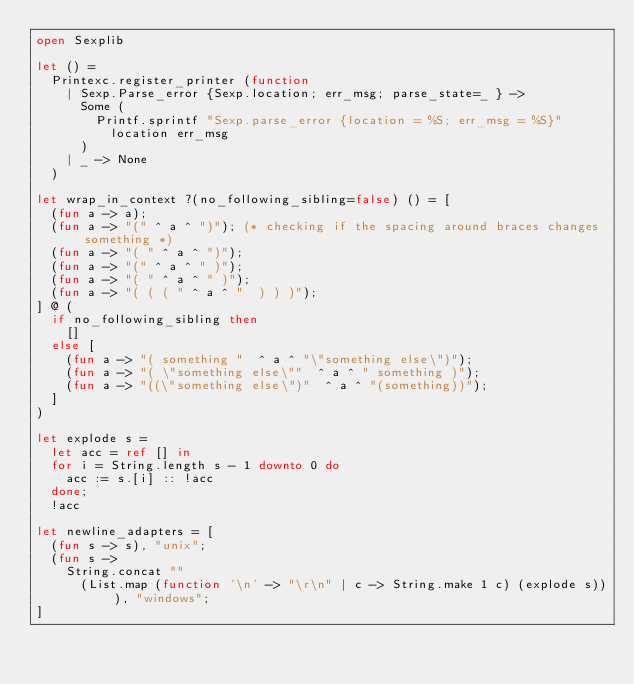<code> <loc_0><loc_0><loc_500><loc_500><_OCaml_>open Sexplib

let () =
  Printexc.register_printer (function
    | Sexp.Parse_error {Sexp.location; err_msg; parse_state=_ } ->
      Some (
        Printf.sprintf "Sexp.parse_error {location = %S; err_msg = %S}"
          location err_msg
      )
    | _ -> None
  )

let wrap_in_context ?(no_following_sibling=false) () = [
  (fun a -> a);
  (fun a -> "(" ^ a ^ ")"); (* checking if the spacing around braces changes something *)
  (fun a -> "( " ^ a ^ ")");
  (fun a -> "(" ^ a ^ " )");
  (fun a -> "( " ^ a ^ " )");
  (fun a -> "( ( ( " ^ a ^ "  ) ) )");
] @ (
  if no_following_sibling then
    []
  else [
    (fun a -> "( something "  ^ a ^ "\"something else\")");
    (fun a -> "( \"something else\""  ^ a ^ " something )");
    (fun a -> "((\"something else\")"  ^ a ^ "(something))");
  ]
)

let explode s =
  let acc = ref [] in
  for i = String.length s - 1 downto 0 do
    acc := s.[i] :: !acc
  done;
  !acc

let newline_adapters = [
  (fun s -> s), "unix";
  (fun s ->
    String.concat ""
      (List.map (function '\n' -> "\r\n" | c -> String.make 1 c) (explode s))), "windows";
]
</code> 